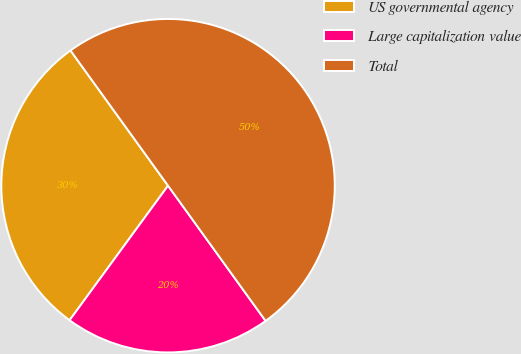Convert chart to OTSL. <chart><loc_0><loc_0><loc_500><loc_500><pie_chart><fcel>US governmental agency<fcel>Large capitalization value<fcel>Total<nl><fcel>30.0%<fcel>20.0%<fcel>50.0%<nl></chart> 